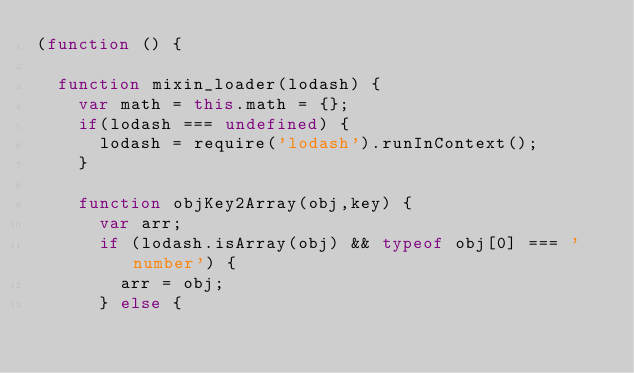Convert code to text. <code><loc_0><loc_0><loc_500><loc_500><_JavaScript_>(function () {
  
  function mixin_loader(lodash) {
    var math = this.math = {};
    if(lodash === undefined) {    
      lodash = require('lodash').runInContext();
    }
   
    function objKey2Array(obj,key) {
      var arr;
      if (lodash.isArray(obj) && typeof obj[0] === 'number') {
        arr = obj;
      } else {</code> 